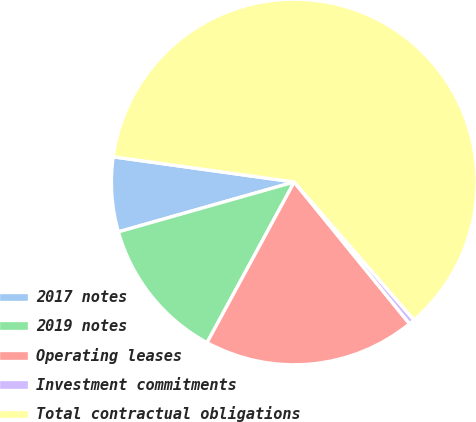Convert chart. <chart><loc_0><loc_0><loc_500><loc_500><pie_chart><fcel>2017 notes<fcel>2019 notes<fcel>Operating leases<fcel>Investment commitments<fcel>Total contractual obligations<nl><fcel>6.6%<fcel>12.69%<fcel>18.78%<fcel>0.51%<fcel>61.42%<nl></chart> 